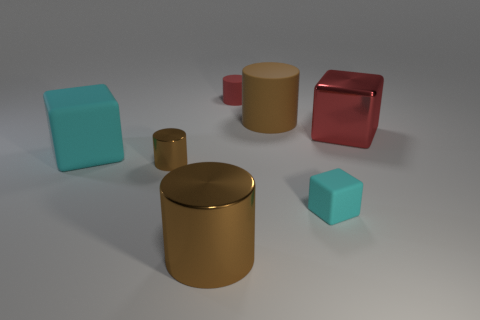Subtract all brown cylinders. How many were subtracted if there are1brown cylinders left? 2 Subtract all gray blocks. How many brown cylinders are left? 3 Subtract 1 cylinders. How many cylinders are left? 3 Add 2 purple metal blocks. How many objects exist? 9 Subtract all cylinders. How many objects are left? 3 Add 5 red cylinders. How many red cylinders are left? 6 Add 3 tiny blue matte balls. How many tiny blue matte balls exist? 3 Subtract 0 gray cubes. How many objects are left? 7 Subtract all blue metallic blocks. Subtract all tiny cyan objects. How many objects are left? 6 